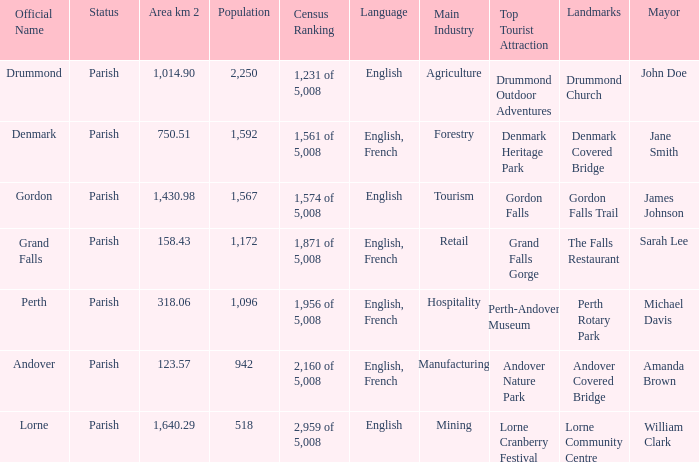What is the area of the parish with a population larger than 1,172 and a census ranking of 1,871 of 5,008? 0.0. 